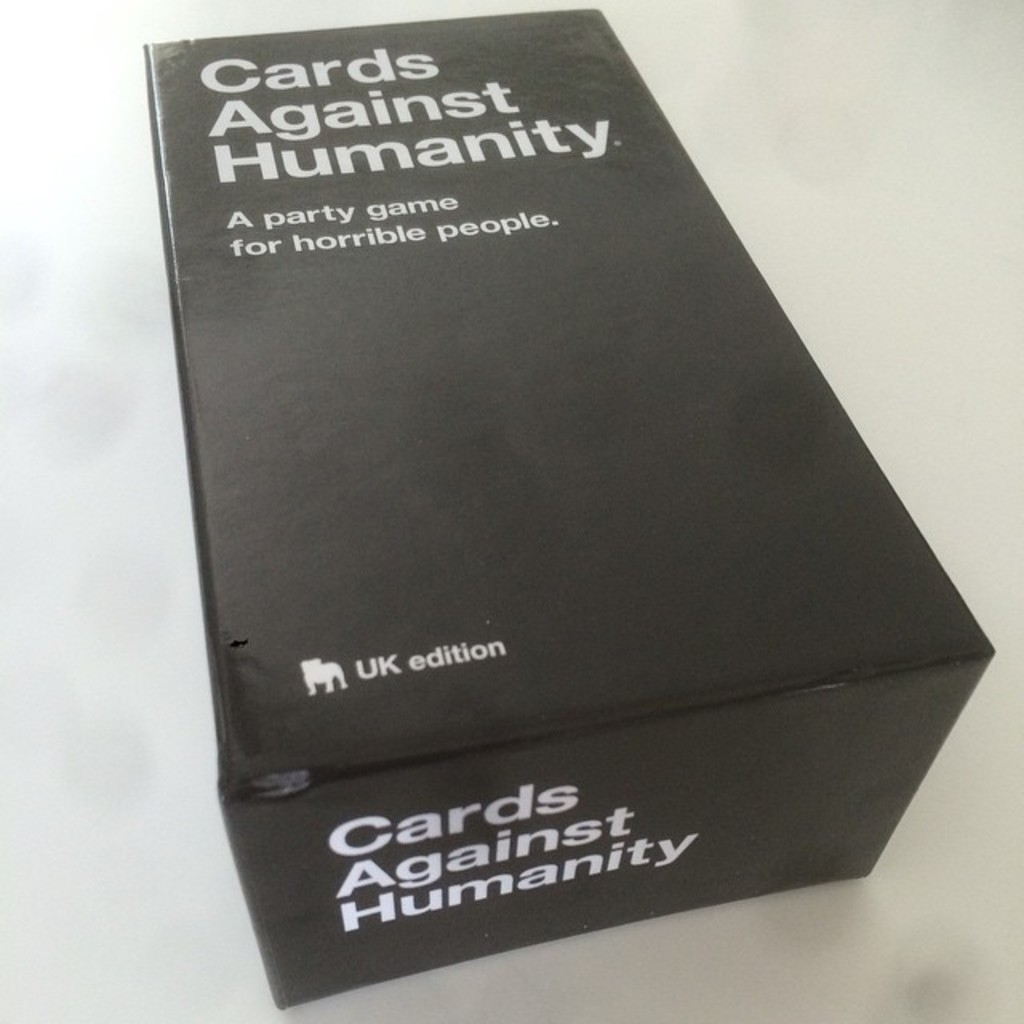Can you explain the significance of the minimalistic design on the game's packaging? The minimalistic design of the 'Cards Against Humanity' box, with its stark black background and bold white text, serves a dual purpose. It reflects the game's straightforward yet provocative style, where humor and shock value are delivered in simple card formats. Additionally, the uncluttered design may help it stand out in a market crowded with more vibrantly packaged games, emphasizing the unique nature of its content. 